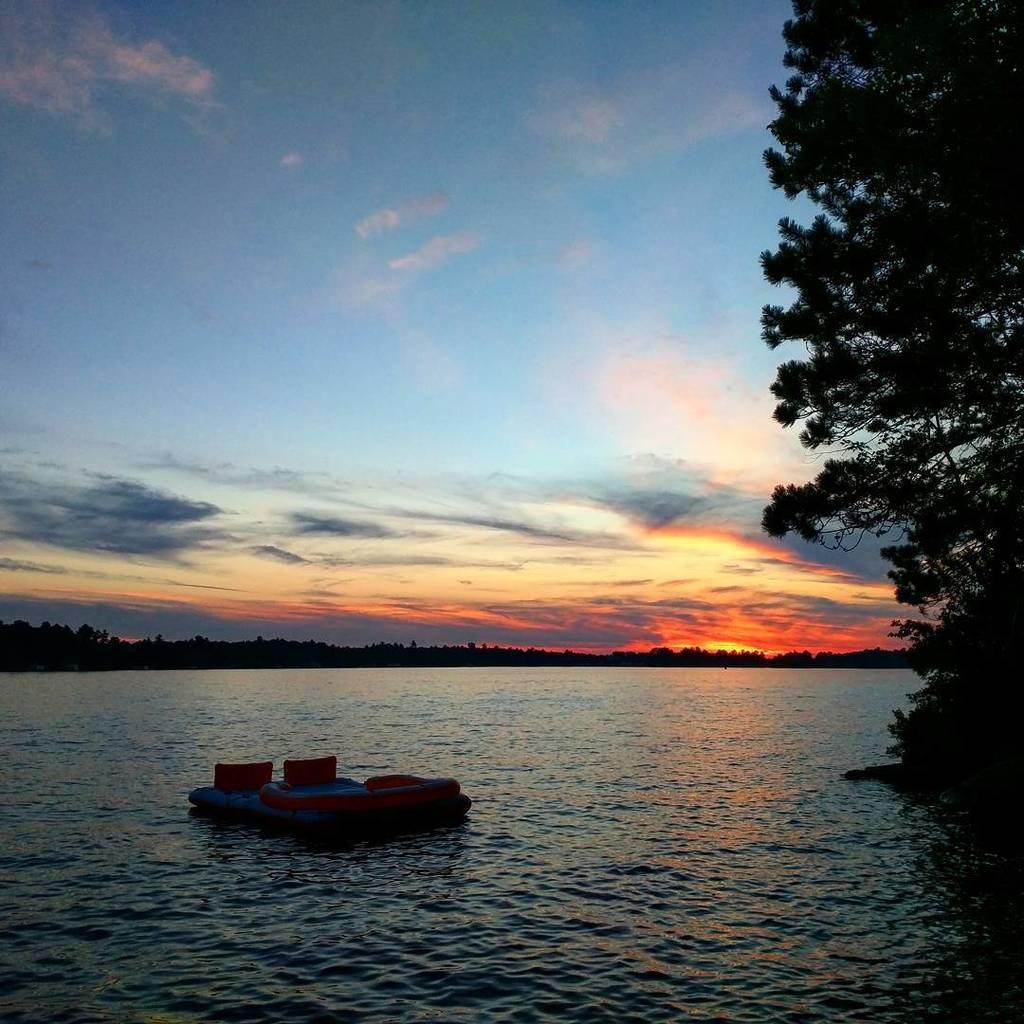Please provide a concise description of this image. In this image we can see one lake, one small boat on the lake, some trees, some bushes, some grass around the lake and at the top there is the reddish blue sky. 